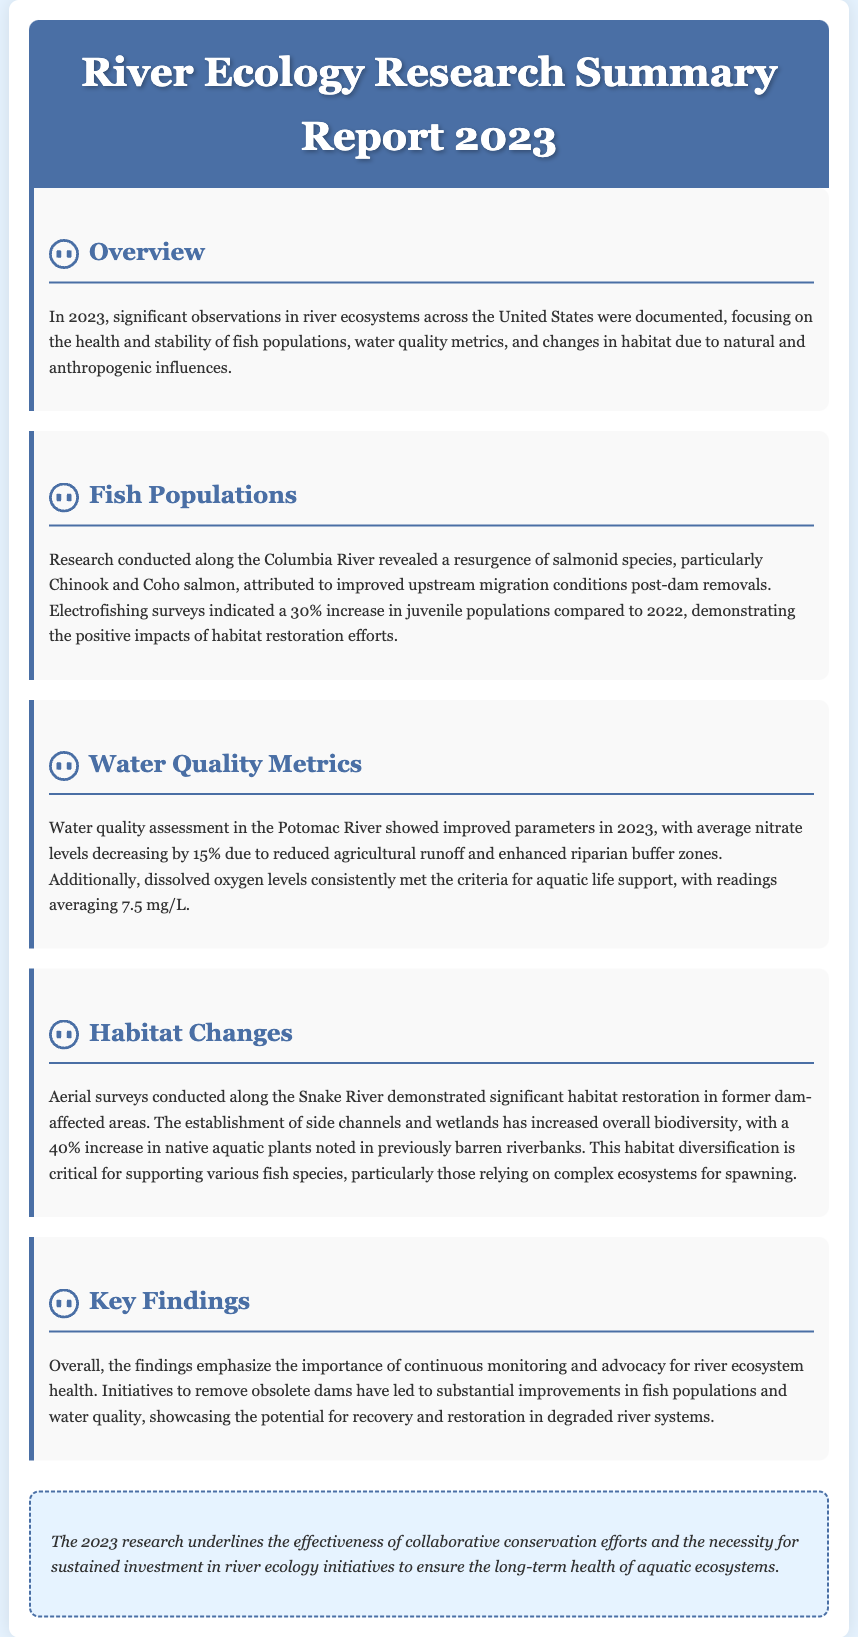what species of salmon showed a resurgence in the Columbia River? The document mentions a resurgence of Chinook and Coho salmon in the Columbia River due to improved migration conditions.
Answer: Chinook and Coho salmon by what percentage did juvenile fish populations increase in 2023 compared to 2022? The report states that there was a 30% increase in juvenile populations as observed in electrofishing surveys.
Answer: 30% what was the average decrease in nitrate levels in the Potomac River? The assessment indicated a decrease in average nitrate levels by 15% due to reduced agricultural runoff.
Answer: 15% how much did dissolved oxygen levels average in the Potomac River? The document notes that dissolved oxygen levels averaged 7.5 mg/L, meeting aquatic life support criteria.
Answer: 7.5 mg/L how much did the native aquatic plant population increase in Snake River's restored habitats? The report highlights a 40% increase in native aquatic plants in previously barren riverbanks following habitat restoration.
Answer: 40% what is the overall conclusion of the 2023 River Ecology Research? The conclusion emphasizes the effectiveness of conservation efforts and the need for sustained investment in river ecology initiatives.
Answer: Effectiveness of conservation efforts what type of river ecosystem change was documented in the Snake River? Aerial surveys demonstrated significant habitat restoration, particularly the establishment of side channels and wetlands.
Answer: Habitat restoration which river demonstrated improved water quality parameters due to better land management practices? The document specifies that water quality metrics improved in the Potomac River as a result of reduced agricultural runoff.
Answer: Potomac River 